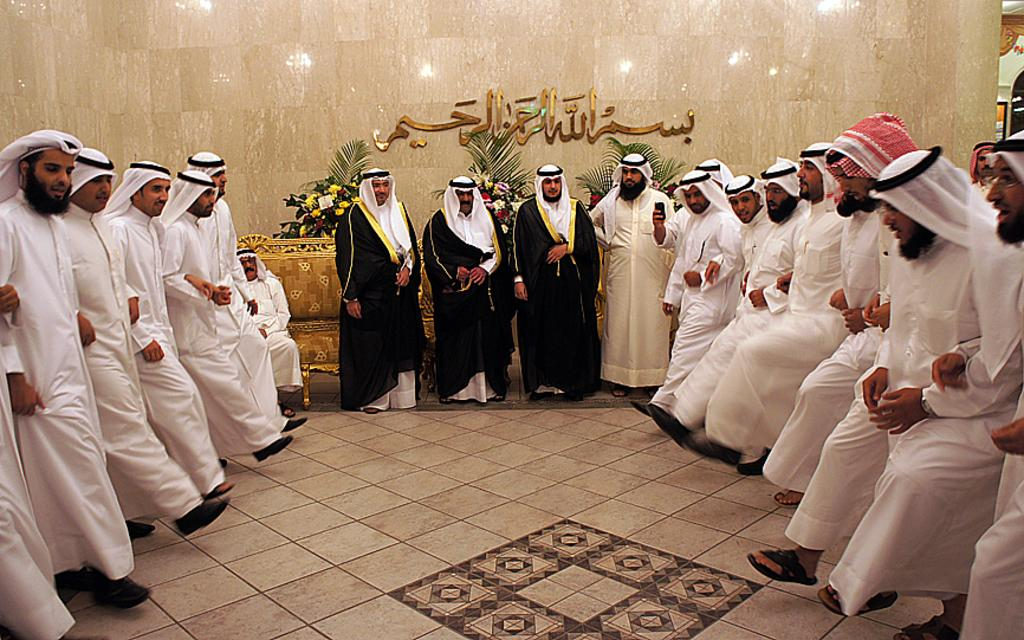What is the main subject of the image? The main subject of the image is a group of people. What are the people in the image doing? The people are standing. Can you describe the man in the image? There is a man sitting on a sofa in the image. What can be seen in the background of the image? There are plants and text on a wall in the background of the image. What type of blade is being used to cut the oatmeal in the image? There is no blade or oatmeal present in the image. How many circles can be seen in the image? There is no circle present in the image. 